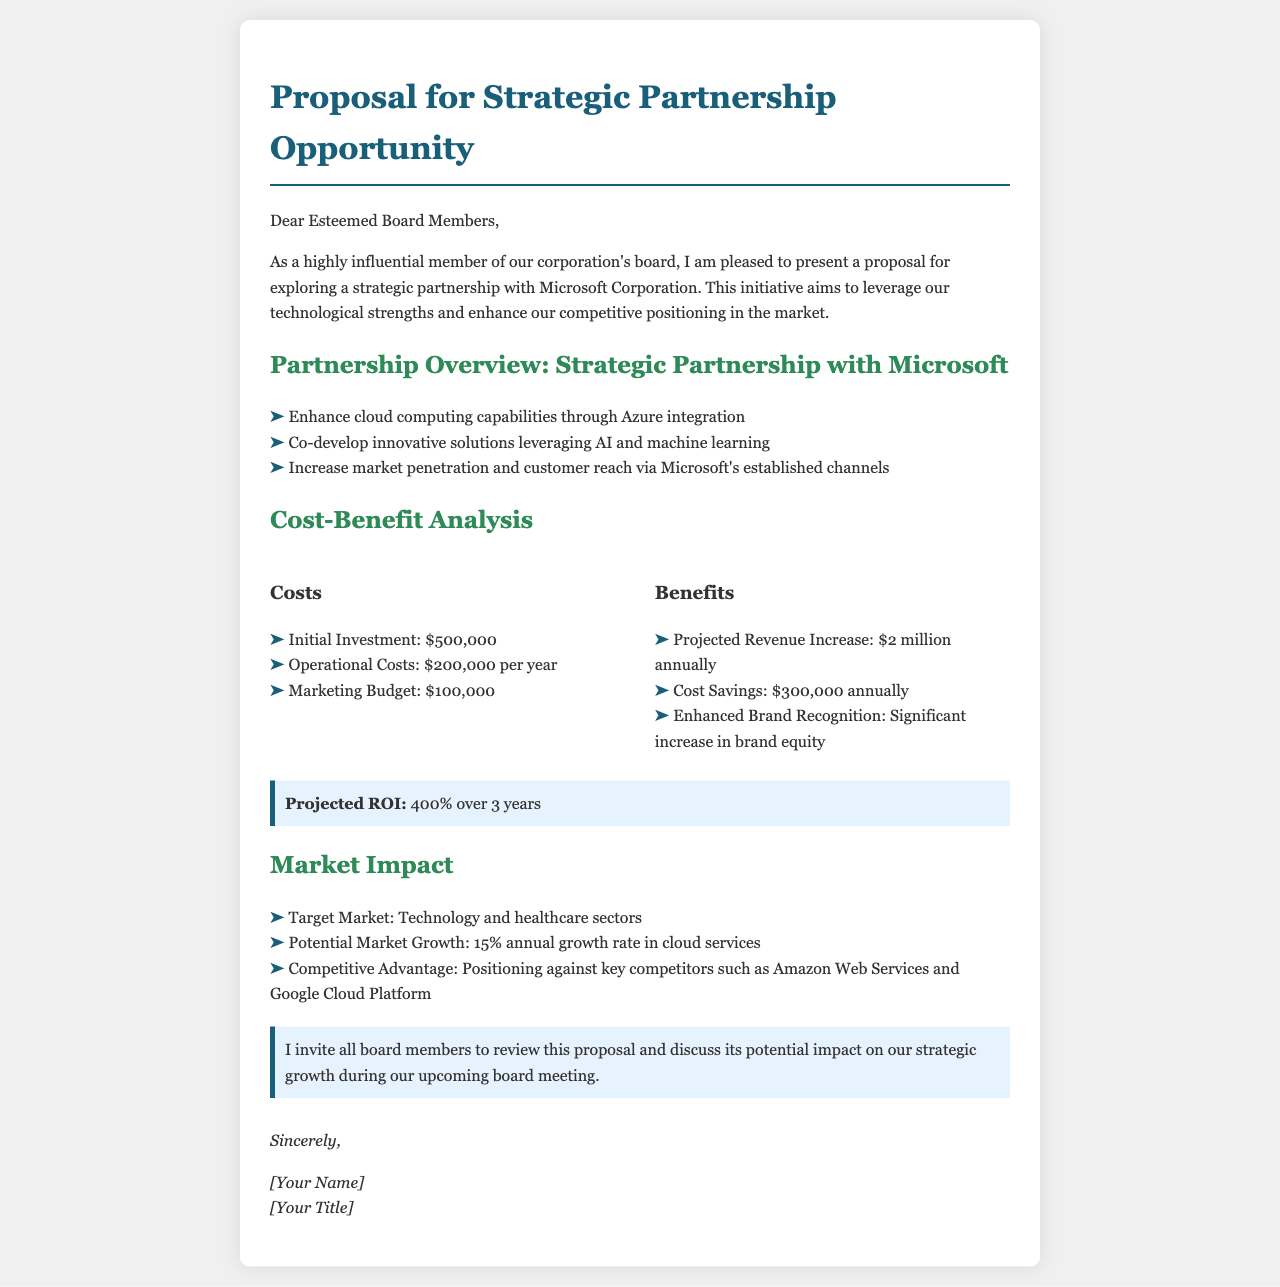what is the initial investment? The initial investment is stated as a cost in the document.
Answer: $500,000 what is the projected revenue increase? The projected revenue increase is mentioned in the benefits section of the cost-benefit analysis.
Answer: $2 million annually what are the target markets? The document specifies the sectors targeted by the strategic partnership.
Answer: Technology and healthcare sectors what is the annual operational cost? This is a specific cost mentioned in the cost-benefit analysis under costs.
Answer: $200,000 per year what is the expected ROI over 3 years? The projected ROI is highlighted in the cost-benefit analysis section.
Answer: 400% what is one main competitive advantage mentioned? The document discusses the positioning against competitors as a key aspect of market impact.
Answer: Positioning against key competitors what is the marketing budget? The marketing budget is detailed in the cost section of the proposal.
Answer: $100,000 what is the potential market growth rate? This detail is given in the market impact section addressing market trends.
Answer: 15% annual growth rate how many years is the cost-benefit analysis projected for? The document indicates the time frame for the ROI projection in the cost-benefit analysis.
Answer: 3 years 